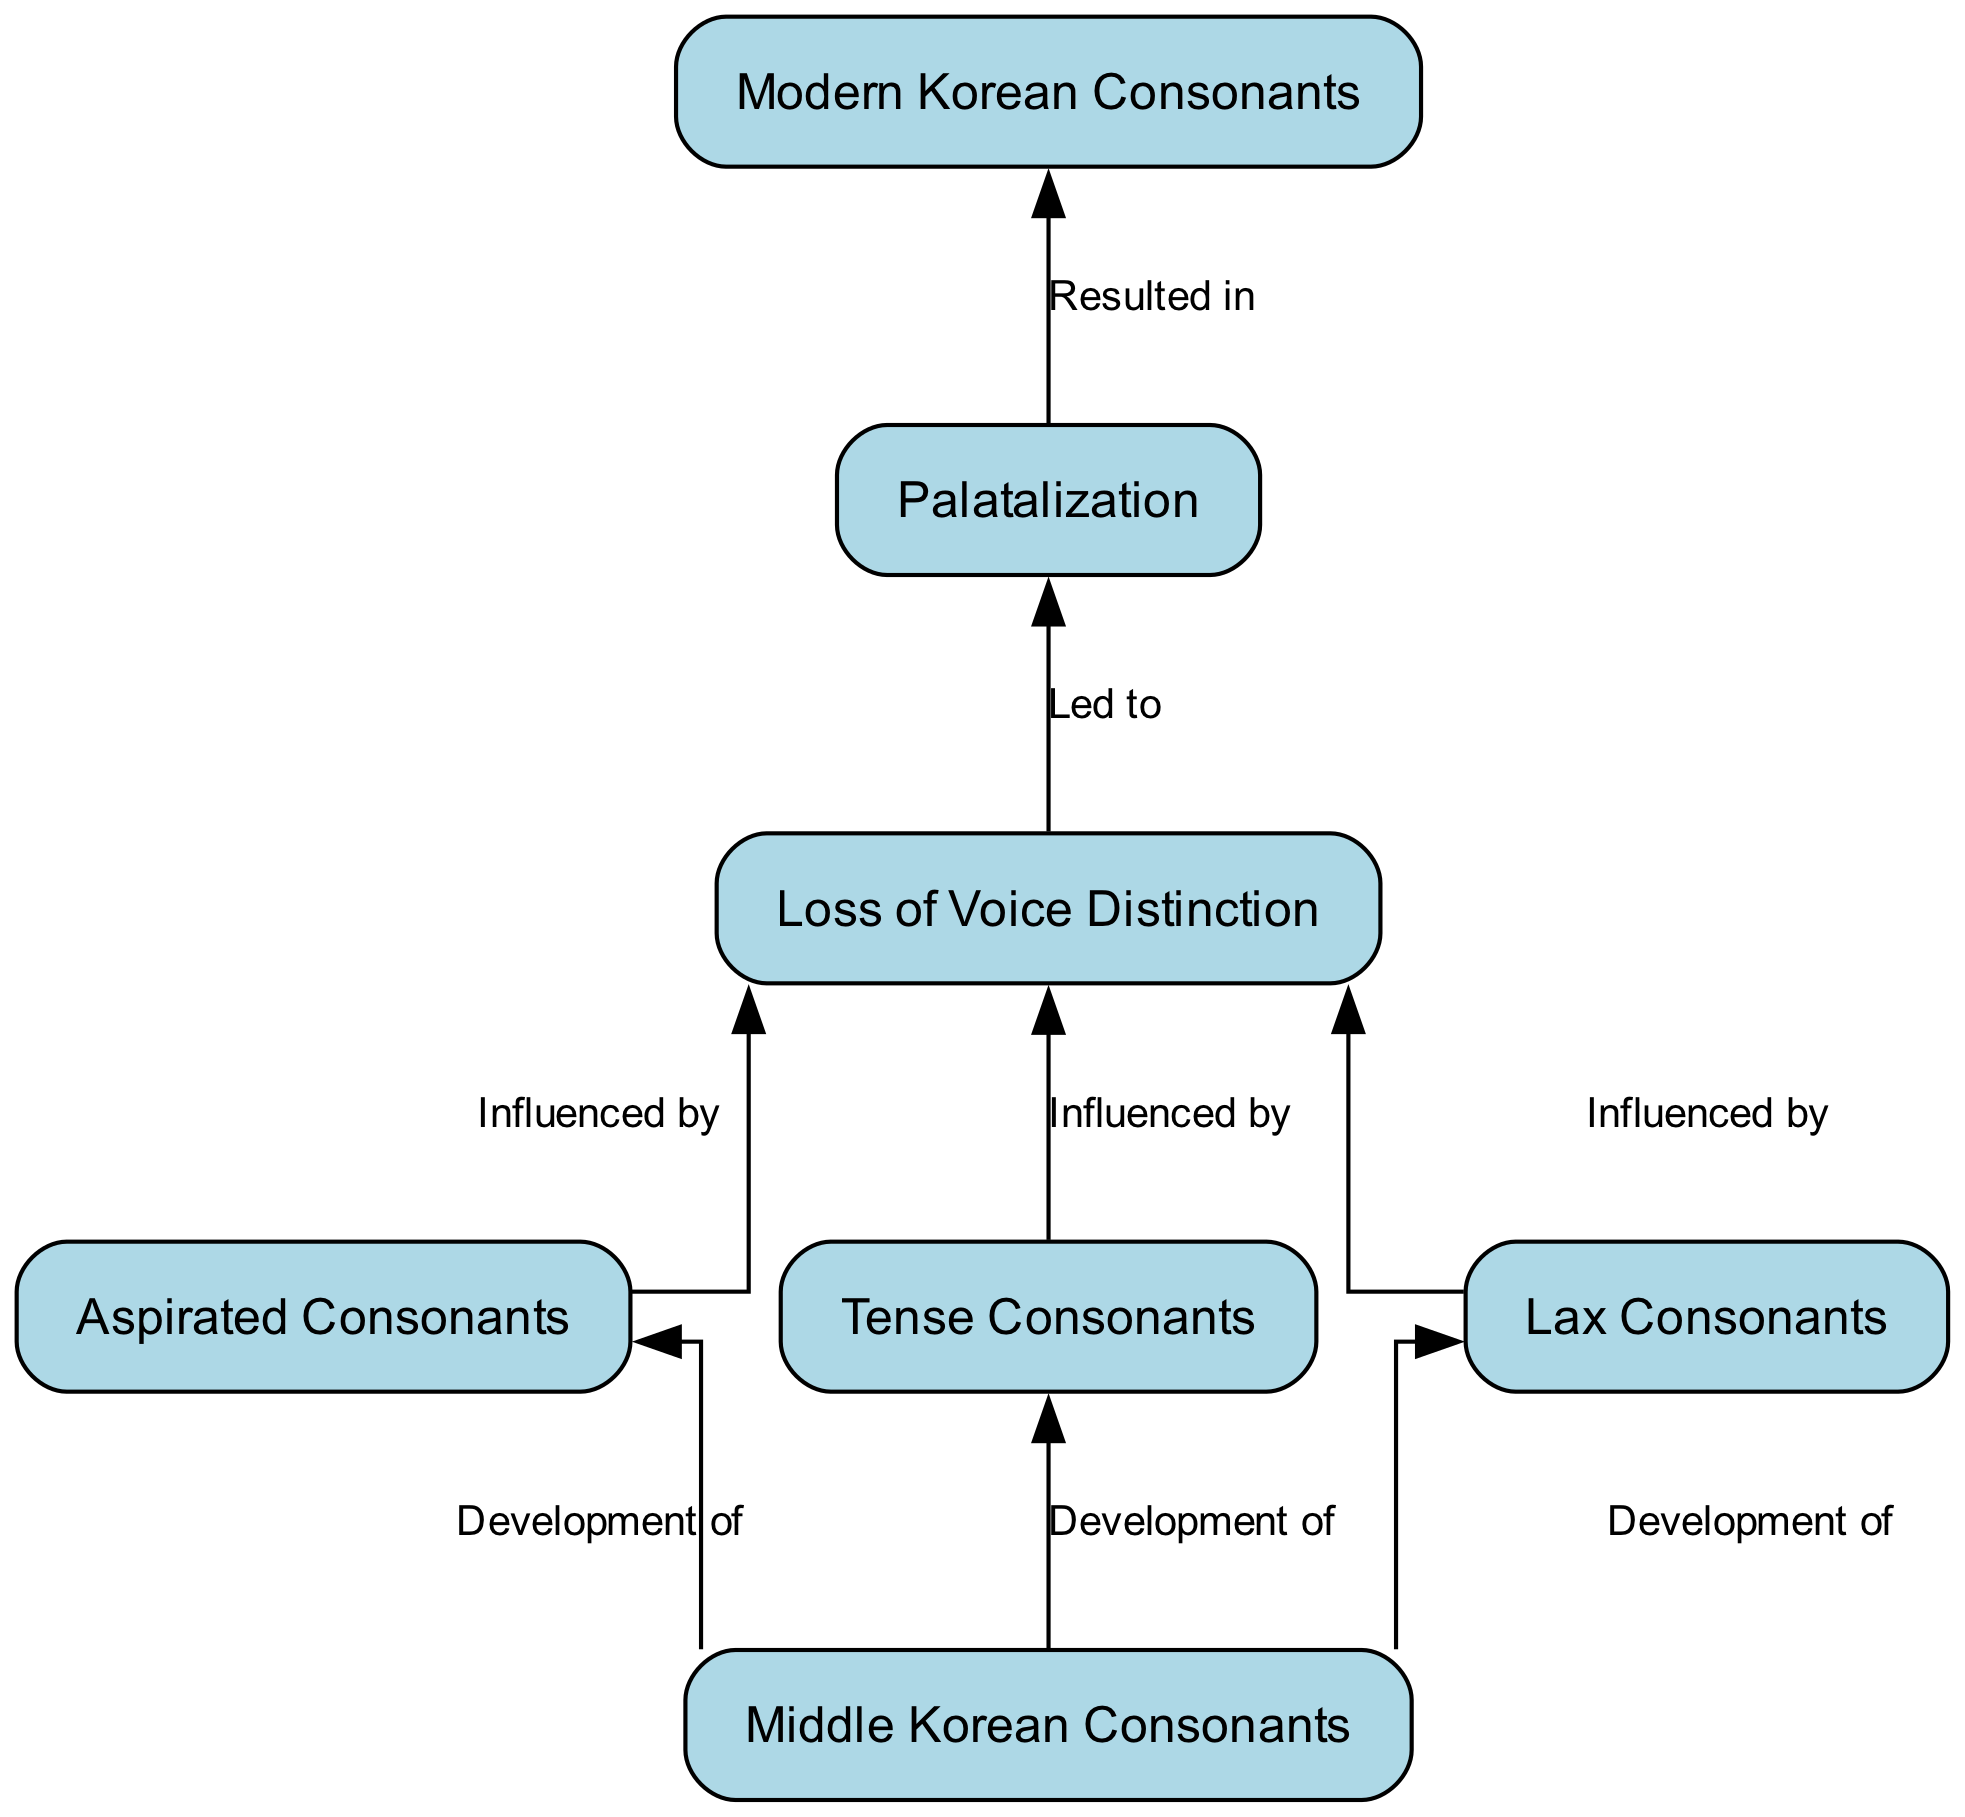What is the starting point of the flow in the diagram? The flow starts from the node labeled "Middle Korean Consonants". This is identified as the first node in the diagram, indicating it serves as the primary subject of the evolution depicted.
Answer: Middle Korean Consonants How many types of consonants are shown in the diagram? The diagram presents three types of consonants: Aspirated Consonants, Tense Consonants, and Lax Consonants. These are illustrated as separate nodes connected to the "Middle Korean Consonants" node, showing they are developments from it.
Answer: Three What is the relationship between "Lax Consonants" and "Loss of Voice Distinction"? The relationship is that "Lax Consonants" is influenced by "Loss of Voice Distinction". This is indicated by an edge pointing from "Lax Consonants" to "Loss of Voice Distinction" labeled "Influenced by".
Answer: Influenced by What leads to "Palatalization" in the flow? "Loss of Voice Distinction" leads to "Palatalization", as shown by the directed edge from "Loss of Voice Distinction" to "Palatalization" labeled "Led to". This indicates a progression in the evolution process.
Answer: Led to Which node represents the final outcome of the evolution process? The final outcome of the evolution process is represented by the node "Modern Korean Consonants". This node is located at the bottom of the diagram, receiving input from "Palatalization".
Answer: Modern Korean Consonants How many edges connect "Middle Korean Consonants" to other nodes? There are three edges connecting "Middle Korean Consonants" to other nodes: one to "Aspirated Consonants", one to "Tense Consonants", and one to "Lax Consonants". Each edge represents a development from the starting point.
Answer: Three What does "Palatalization" result in? "Palatalization" results in "Modern Korean Consonants", as indicated by a direct edge from "Palatalization" to "Modern Korean Consonants" labeled "Resulted in". This indicates the final transformation in the consonant evolution process.
Answer: Resulted in How do "Aspirated Consonants", "Tense Consonants", and "Lax Consonants" collectively relate to "Loss of Voice Distinction"? Collectively, all three types of consonants influence "Loss of Voice Distinction", as shown by directed edges from each to it labeled "Influenced by". This indicates that they contributed to this phonetic change.
Answer: Influenced by What is the total number of nodes in the diagram? The total number of nodes in the diagram is seven. This includes all the distinct categories of consonants and the central and final nodes in the flow.
Answer: Seven 